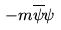<formula> <loc_0><loc_0><loc_500><loc_500>- m \overline { \psi } \psi</formula> 